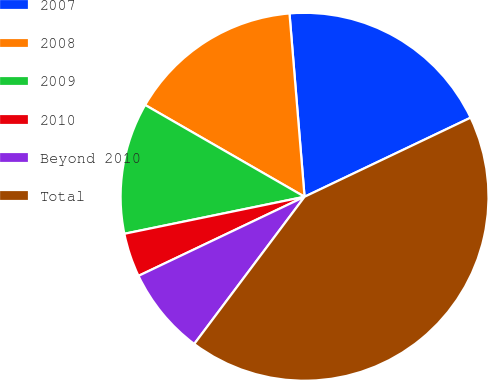<chart> <loc_0><loc_0><loc_500><loc_500><pie_chart><fcel>2007<fcel>2008<fcel>2009<fcel>2010<fcel>Beyond 2010<fcel>Total<nl><fcel>19.23%<fcel>15.38%<fcel>11.54%<fcel>3.85%<fcel>7.69%<fcel>42.31%<nl></chart> 